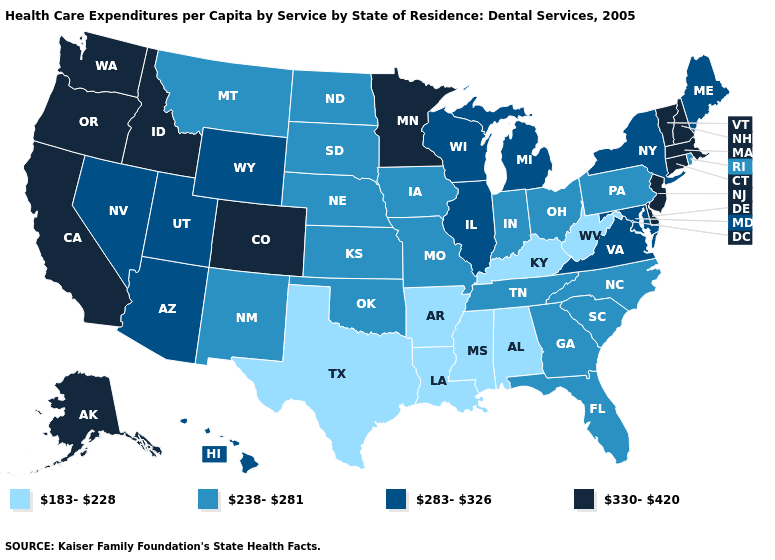Does Alabama have the lowest value in the South?
Be succinct. Yes. Does Rhode Island have a higher value than North Dakota?
Be succinct. No. Does Arkansas have a lower value than Louisiana?
Keep it brief. No. Which states have the highest value in the USA?
Answer briefly. Alaska, California, Colorado, Connecticut, Delaware, Idaho, Massachusetts, Minnesota, New Hampshire, New Jersey, Oregon, Vermont, Washington. Does Pennsylvania have the same value as Idaho?
Give a very brief answer. No. Which states hav the highest value in the South?
Keep it brief. Delaware. Name the states that have a value in the range 330-420?
Keep it brief. Alaska, California, Colorado, Connecticut, Delaware, Idaho, Massachusetts, Minnesota, New Hampshire, New Jersey, Oregon, Vermont, Washington. Does Ohio have a higher value than South Carolina?
Keep it brief. No. Does the first symbol in the legend represent the smallest category?
Concise answer only. Yes. What is the lowest value in the USA?
Concise answer only. 183-228. How many symbols are there in the legend?
Quick response, please. 4. Does Pennsylvania have the same value as Mississippi?
Keep it brief. No. What is the highest value in the West ?
Concise answer only. 330-420. Which states hav the highest value in the West?
Write a very short answer. Alaska, California, Colorado, Idaho, Oregon, Washington. Name the states that have a value in the range 238-281?
Quick response, please. Florida, Georgia, Indiana, Iowa, Kansas, Missouri, Montana, Nebraska, New Mexico, North Carolina, North Dakota, Ohio, Oklahoma, Pennsylvania, Rhode Island, South Carolina, South Dakota, Tennessee. 